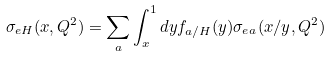Convert formula to latex. <formula><loc_0><loc_0><loc_500><loc_500>\sigma _ { e H } ( x , Q ^ { 2 } ) = \sum _ { a } \int _ { x } ^ { 1 } d y f _ { a / H } ( y ) \sigma _ { e a } ( x / y , Q ^ { 2 } )</formula> 